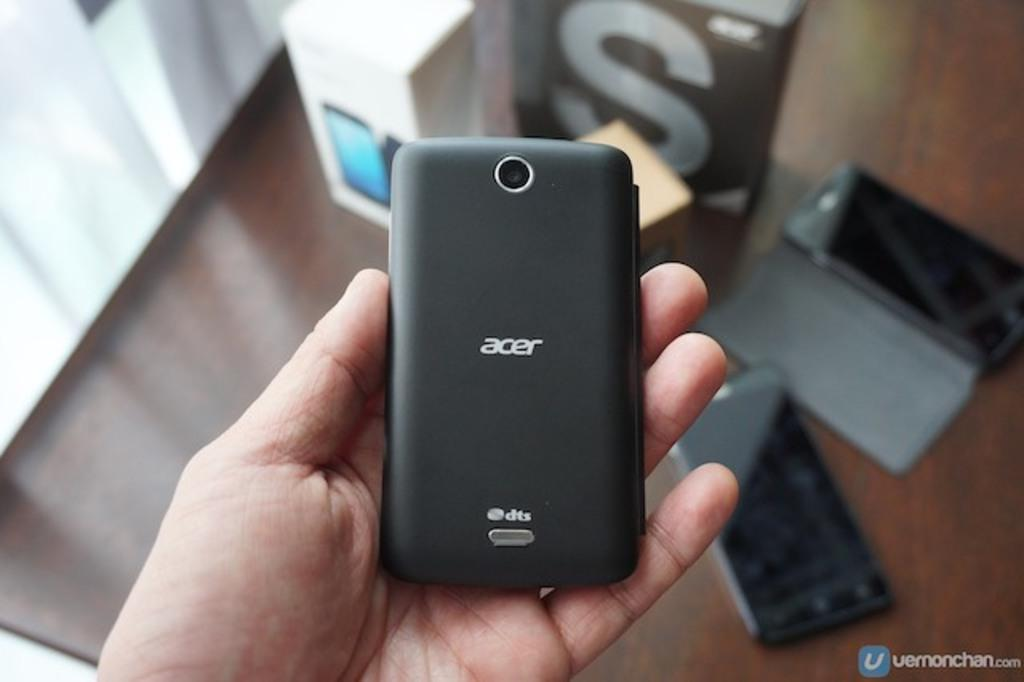<image>
Present a compact description of the photo's key features. A black Acer phone sitting upside down in a man's palm. 